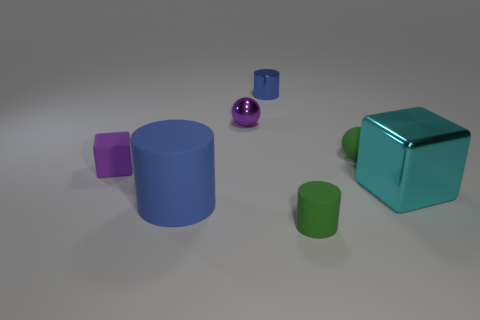Add 3 small cyan rubber cylinders. How many objects exist? 10 Subtract all cylinders. How many objects are left? 4 Subtract 0 red balls. How many objects are left? 7 Subtract all large cyan metallic things. Subtract all small objects. How many objects are left? 1 Add 4 blue metal objects. How many blue metal objects are left? 5 Add 2 tiny green cylinders. How many tiny green cylinders exist? 3 